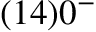Convert formula to latex. <formula><loc_0><loc_0><loc_500><loc_500>( 1 4 ) 0 ^ { - }</formula> 